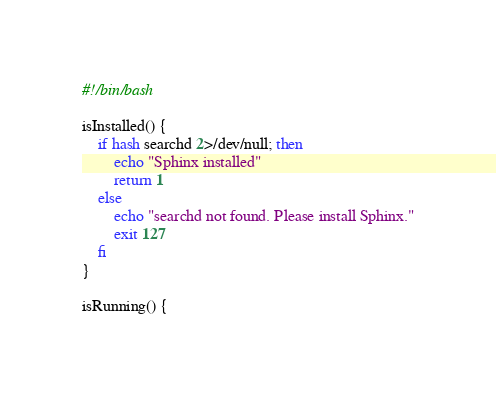<code> <loc_0><loc_0><loc_500><loc_500><_Bash_>#!/bin/bash

isInstalled() {
    if hash searchd 2>/dev/null; then
        echo "Sphinx installed"
        return 1
    else
        echo "searchd not found. Please install Sphinx."
        exit 127
    fi
}

isRunning() {</code> 